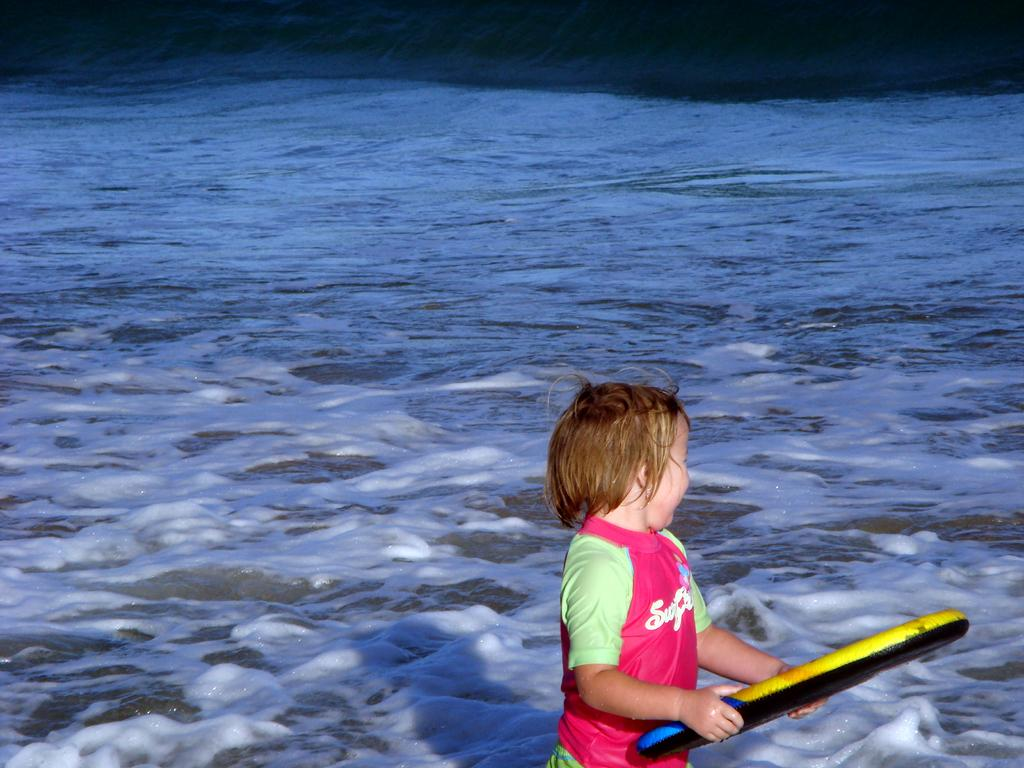What is the main subject of the image? There is a boy in the image. What is the boy holding in the image? The boy is holding an object. What can be seen in the background of the image? There is water visible in the background of the image. What type of sticks is the boy using to control the beast in the image? There is no beast or sticks present in the image. 